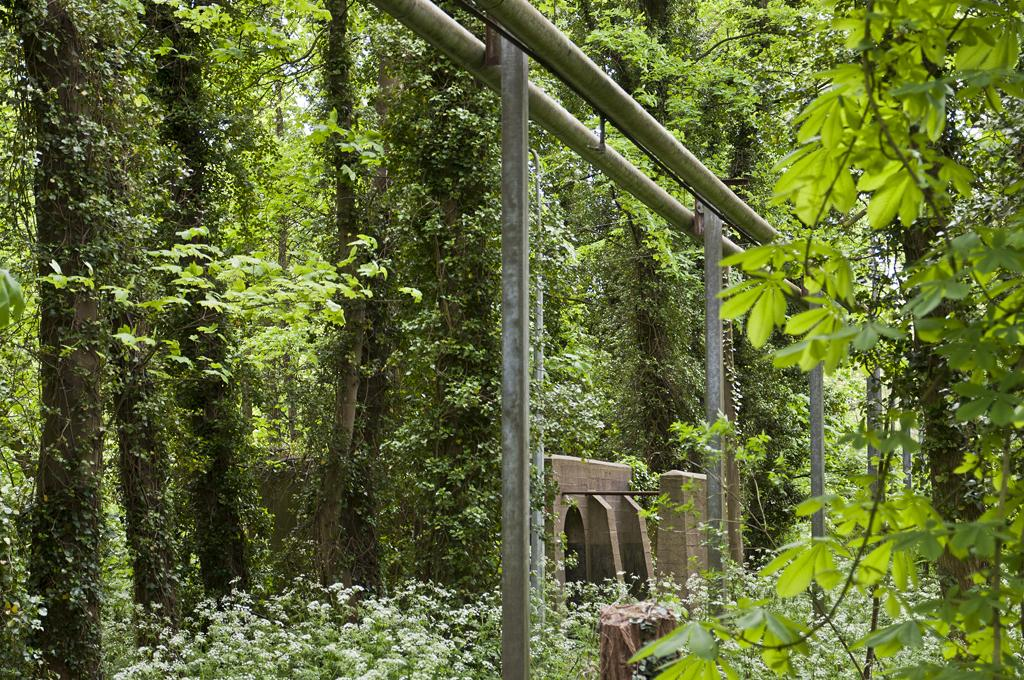What type of vegetation can be seen in the image? There are trees and plants in the image. What objects are located in the middle of the image? There are poles in the middle of the image. What type of pollution can be seen in the image? There is no pollution visible in the image. Is there a mountain visible in the image? There is no mountain present in the image. 